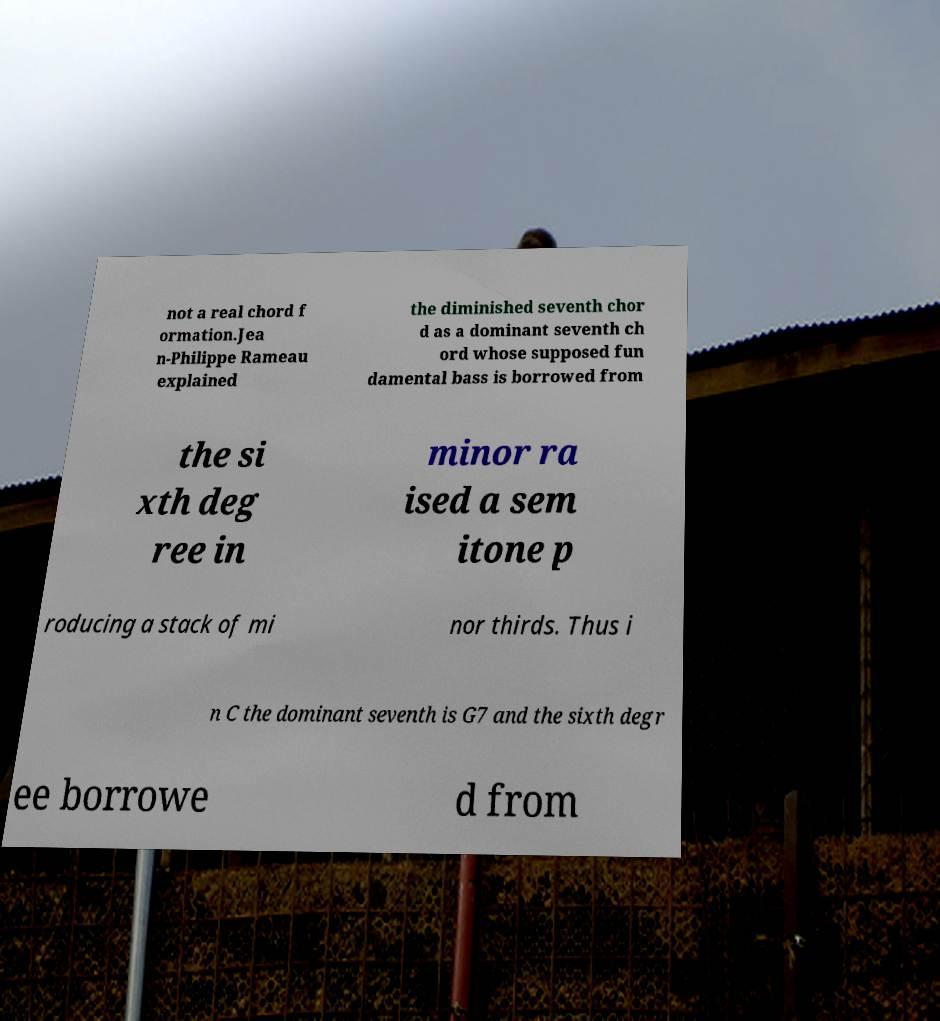Could you assist in decoding the text presented in this image and type it out clearly? not a real chord f ormation.Jea n-Philippe Rameau explained the diminished seventh chor d as a dominant seventh ch ord whose supposed fun damental bass is borrowed from the si xth deg ree in minor ra ised a sem itone p roducing a stack of mi nor thirds. Thus i n C the dominant seventh is G7 and the sixth degr ee borrowe d from 